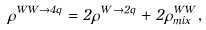<formula> <loc_0><loc_0><loc_500><loc_500>\rho ^ { W W \rightarrow 4 q } = 2 \rho ^ { W \rightarrow 2 q } + 2 \rho _ { m i x } ^ { W W } ,</formula> 